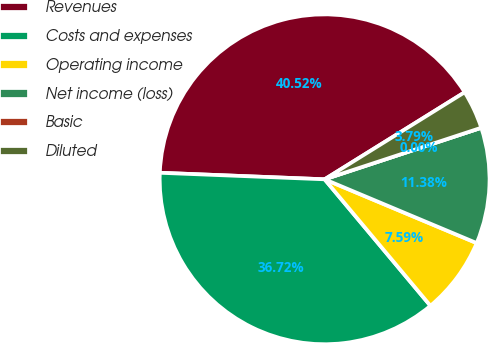Convert chart. <chart><loc_0><loc_0><loc_500><loc_500><pie_chart><fcel>Revenues<fcel>Costs and expenses<fcel>Operating income<fcel>Net income (loss)<fcel>Basic<fcel>Diluted<nl><fcel>40.52%<fcel>36.72%<fcel>7.59%<fcel>11.38%<fcel>0.0%<fcel>3.79%<nl></chart> 